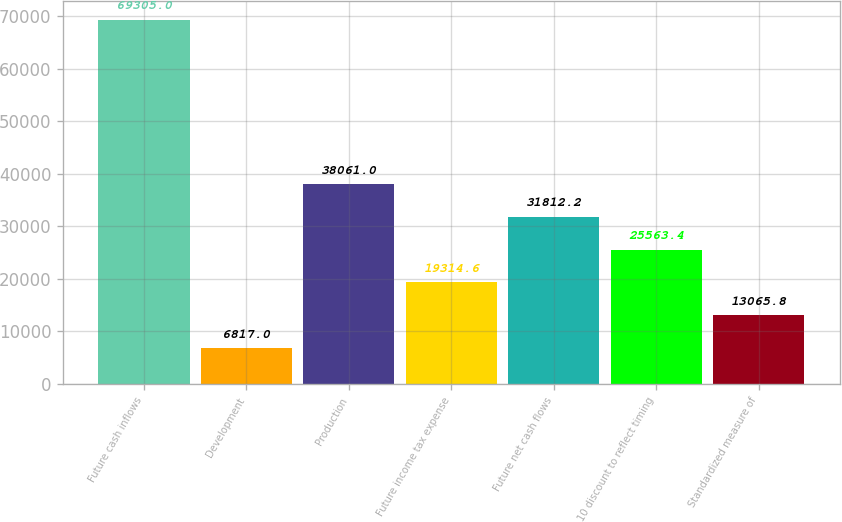Convert chart. <chart><loc_0><loc_0><loc_500><loc_500><bar_chart><fcel>Future cash inflows<fcel>Development<fcel>Production<fcel>Future income tax expense<fcel>Future net cash flows<fcel>10 discount to reflect timing<fcel>Standardized measure of<nl><fcel>69305<fcel>6817<fcel>38061<fcel>19314.6<fcel>31812.2<fcel>25563.4<fcel>13065.8<nl></chart> 